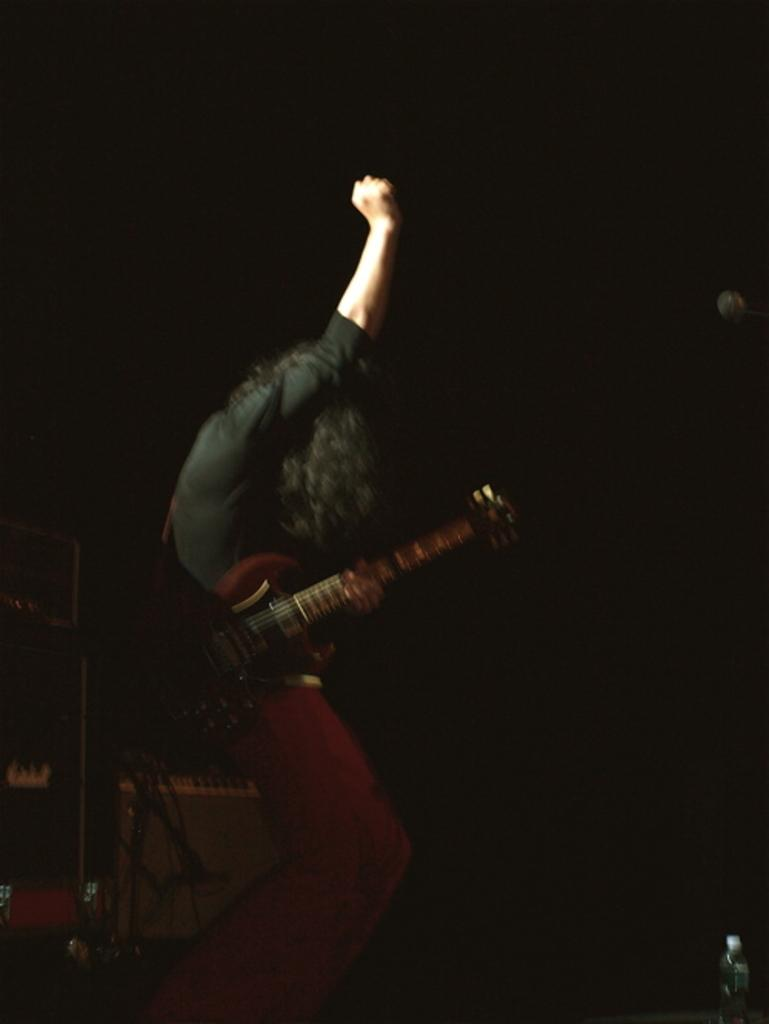What is the main subject of the image? There is a person in the image. What is the person holding in their hands? The person is holding a guitar in their hands. What type of cave can be seen in the background of the image? There is no cave present in the image; it only features a person holding a guitar. How many spots are visible on the guitar in the image? There is no mention of spots on the guitar in the image, as it only shows a person holding a guitar. 